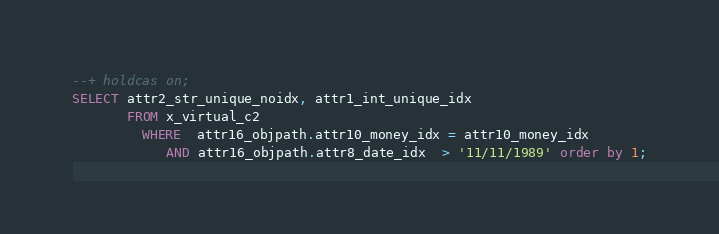Convert code to text. <code><loc_0><loc_0><loc_500><loc_500><_SQL_>--+ holdcas on;
SELECT attr2_str_unique_noidx, attr1_int_unique_idx
       FROM x_virtual_c2
         WHERE  attr16_objpath.attr10_money_idx = attr10_money_idx
            AND attr16_objpath.attr8_date_idx  > '11/11/1989' order by 1;
</code> 